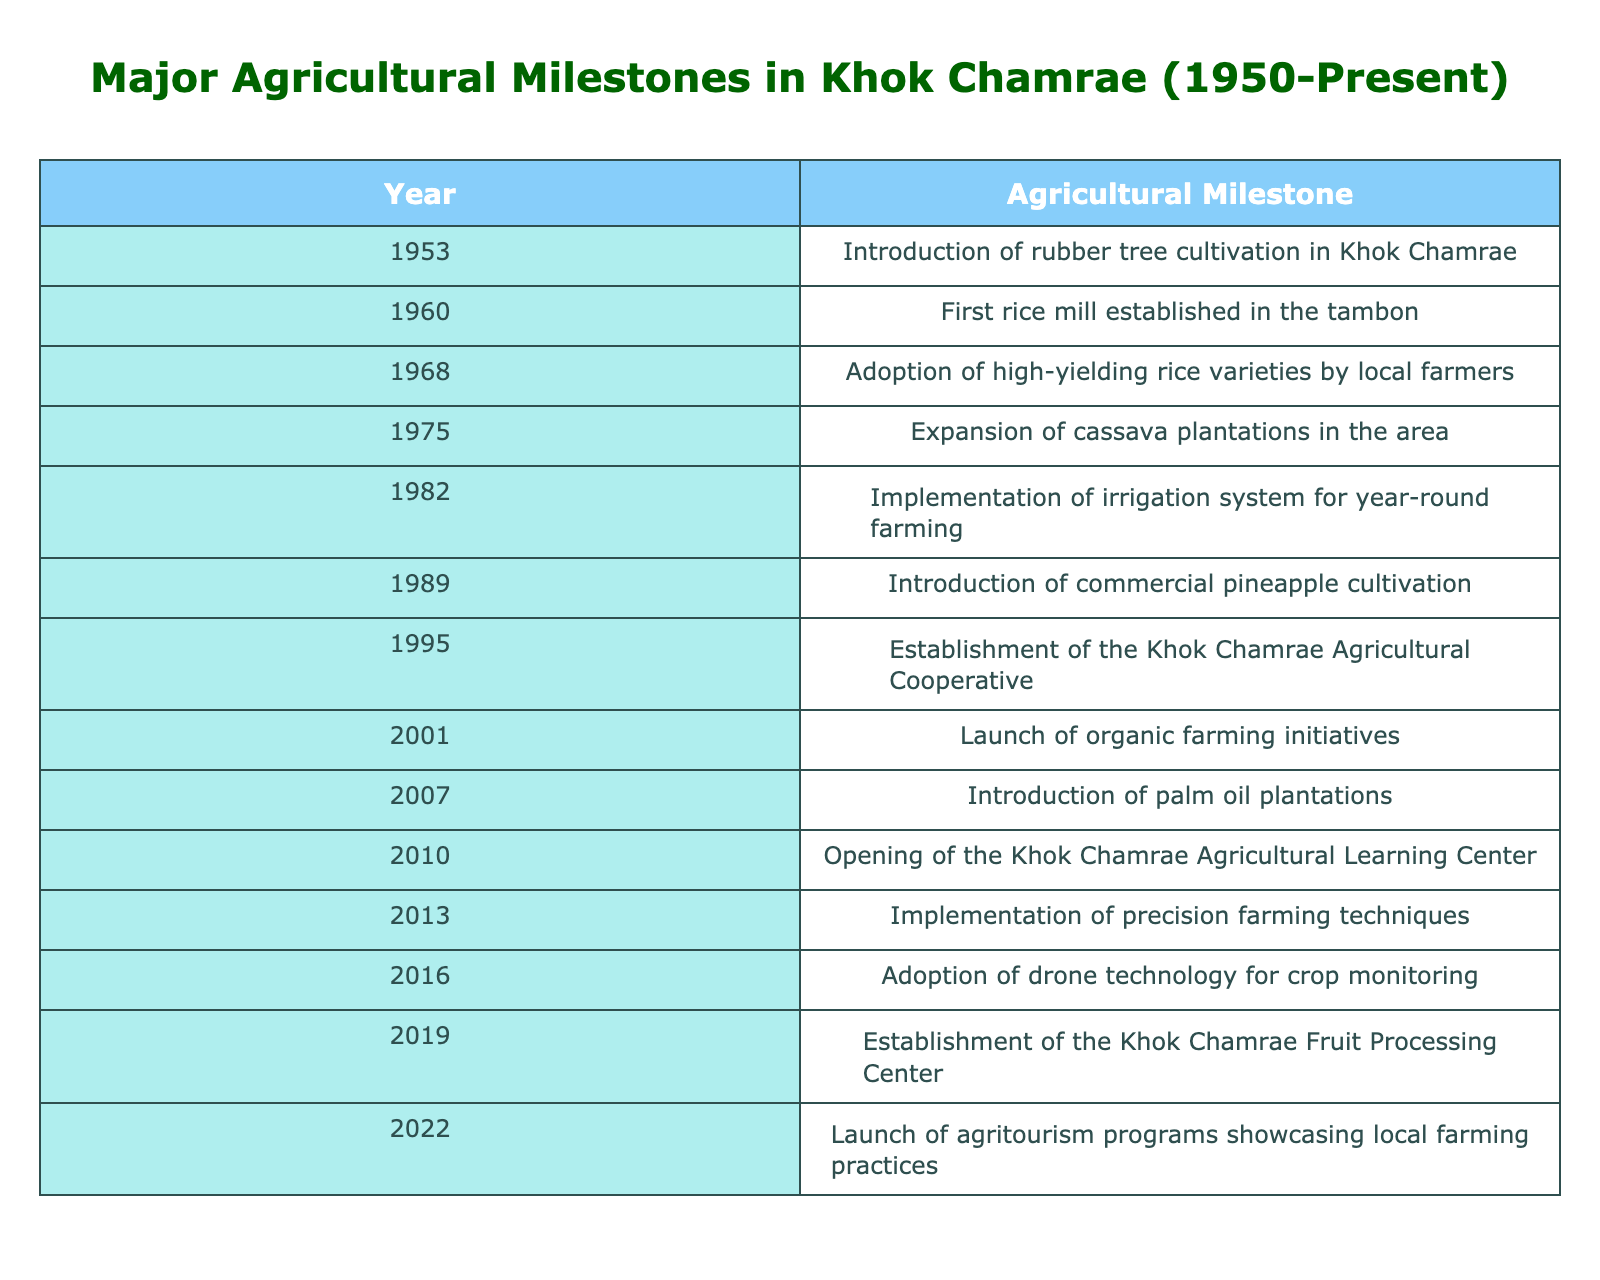What event marked the introduction of rubber tree cultivation in Khok Chamrae? The table indicates that rubber tree cultivation was introduced in Khok Chamrae in 1953.
Answer: Introduction of rubber tree cultivation in Khok Chamrae How many years passed between the establishment of the first rice mill and the adoption of high-yielding rice varieties? The first rice mill was established in 1960, and high-yielding rice varieties were adopted in 1968. The difference is 1968 - 1960 = 8 years.
Answer: 8 years Was there a milestone related to cassava in Khok Chamrae during the 1970s? According to the table, there was an expansion of cassava plantations in 1975, confirming that there was a relevant milestone in the 1970s.
Answer: Yes What event in Khok Chamrae occurred before the establishment of the agricultural cooperative? The table shows that the Khok Chamrae Agricultural Cooperative was established in 1995, and the event that occurred directly before it was the launch of organic farming initiatives in 2001, so this is incorrect. The correct last event was the introduction of commercial pineapple cultivation in 1989.
Answer: Introduction of commercial pineapple cultivation What was the first instance of technology adoption for farming in Khok Chamrae according to the table? The first instance of technology adoption for farming listed in the table is the implementation of an irrigation system in 1982. This shows an early commitment to modernizing farming techniques.
Answer: Implementation of irrigation system for year-round farming How many events related to the introduction of new crops or farming practices occurred between 2000 and 2020? Between 2000 and 2020, the following events occurred: launch of organic farming initiatives in 2001, introduction of palm oil plantations in 2007, implementation of precision farming techniques in 2013, and establishment of the Khok Chamrae Fruit Processing Center in 2019. That totals 4 events.
Answer: 4 events Has Khok Chamrae implemented any agritourism programs recently? Yes, the table specifies that agritourism programs showcasing local farming practices were launched in 2022, confirming this recent initiative.
Answer: Yes What are the two milestones that took the longest time to occur between them, based on the table? By inspecting the events, the longest gap is between the introduction of rubber tree cultivation in 1953 and the opening of the Agricultural Learning Center in 2010, which is 57 years apart.
Answer: 57 years What year did Khok Chamrae adopt drone technology for crop monitoring? The table indicates that drone technology for crop monitoring was adopted in 2016.
Answer: 2016 